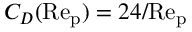<formula> <loc_0><loc_0><loc_500><loc_500>C _ { D } ( R e _ { p } ) = 2 4 / R e _ { p }</formula> 